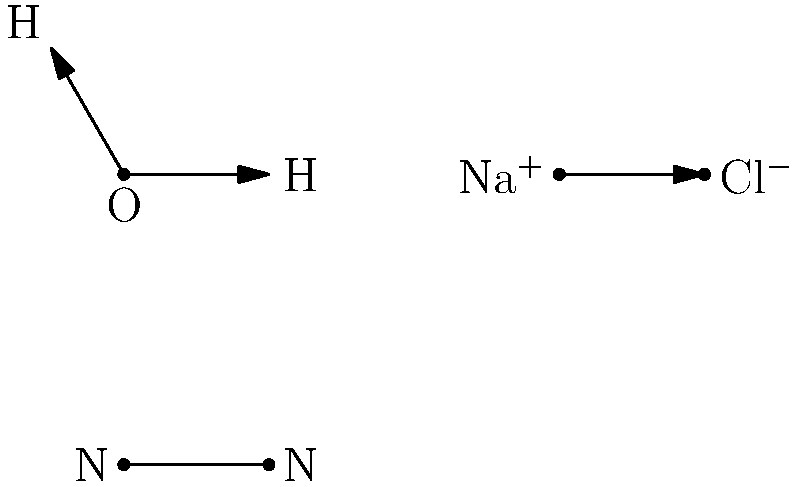Identify the types of chemical bonds present in the molecular structures shown above. Which molecule exhibits a covalent bond? To identify the types of chemical bonds, we need to analyze each molecular structure:

1. H2O (Water):
   - Two single lines with arrows pointing from O to H
   - This represents covalent bonds where electrons are shared between O and H atoms

2. NaCl (Sodium Chloride):
   - Single line with an arrow pointing from Na to Cl
   - Na is labeled with a + charge, Cl with a - charge
   - This represents an ionic bond where electrons are transferred from Na to Cl

3. N2 (Nitrogen):
   - Single line between two N atoms with a double-headed arrow
   - This represents a triple covalent bond where electrons are shared equally between N atoms

Among these, both H2O and N2 exhibit covalent bonds. However, N2 has a triple covalent bond, which is a stronger and more distinctive example of covalent bonding.
Answer: N2 (Nitrogen) 